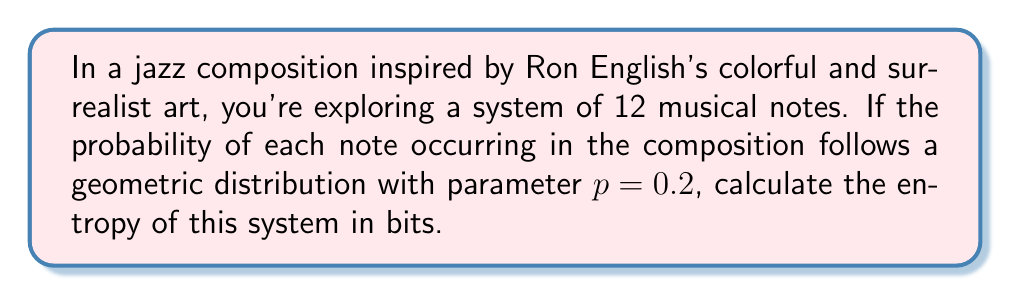Could you help me with this problem? To solve this problem, we'll follow these steps:

1) The entropy of a discrete random variable $X$ is given by:
   $$S = -\sum_{i=1}^n p_i \log_2(p_i)$$
   where $p_i$ is the probability of outcome $i$.

2) For a geometric distribution with parameter $p$, the probability of the $k$-th outcome is:
   $$p_k = p(1-p)^{k-1}$$
   where $k = 1, 2, ..., 12$ in our case.

3) Let's calculate the probabilities for each note:
   $p_1 = 0.2$
   $p_2 = 0.2(1-0.2) = 0.16$
   $p_3 = 0.2(1-0.2)^2 = 0.128$
   ...
   $p_{12} = 0.2(1-0.2)^{11} \approx 0.0069$

4) Now, we can calculate the entropy:
   $$S = -\sum_{k=1}^{12} p_k \log_2(p_k)$$

5) Substituting the values:
   $$S = -[0.2\log_2(0.2) + 0.16\log_2(0.16) + 0.128\log_2(0.128) + ... + 0.0069\log_2(0.0069)]$$

6) Calculating this sum (which can be done with a calculator or computer):
   $$S \approx 3.5095$$

Therefore, the entropy of this system of musical notes is approximately 3.5095 bits.
Answer: 3.5095 bits 